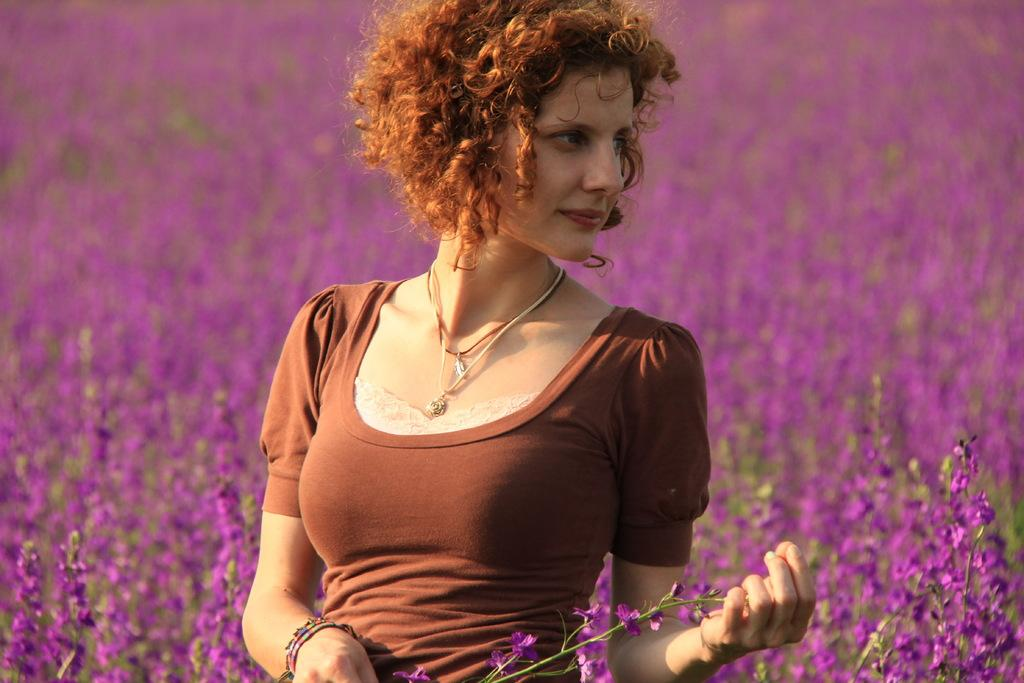Who is the main subject in the image? There is a woman in the image. What is the woman wearing? The woman is wearing a brown dress. What is the woman holding in the image? The woman is holding flowers. What color are the flowers on the plants at the bottom of the image? The flowers on the plants at the bottom of the image are purple. How many cherries can be seen on the wheel in the image? There are no cherries or wheels present in the image. 